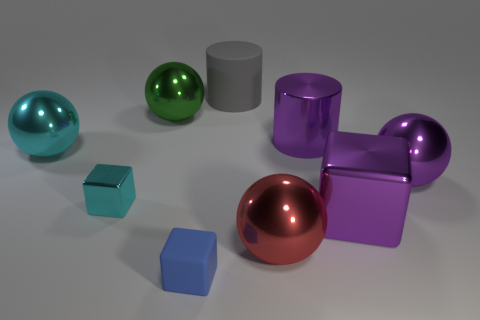Is the number of large shiny objects that are in front of the blue object greater than the number of large red balls?
Give a very brief answer. No. How many other things are there of the same color as the matte cylinder?
Your answer should be compact. 0. There is a gray thing that is the same size as the green metallic ball; what is its shape?
Your response must be concise. Cylinder. How many purple spheres are in front of the purple thing that is in front of the metallic block that is behind the purple block?
Your response must be concise. 0. How many matte things are either large yellow objects or big green objects?
Offer a very short reply. 0. There is a ball that is right of the small matte thing and behind the large cube; what color is it?
Ensure brevity in your answer.  Purple. Do the cylinder in front of the green metal thing and the green metal ball have the same size?
Keep it short and to the point. Yes. What number of things are large things to the right of the big matte cylinder or big red rubber cylinders?
Your response must be concise. 4. Are there any cyan matte cylinders that have the same size as the purple cylinder?
Offer a very short reply. No. There is a object that is the same size as the cyan metal cube; what is its material?
Your answer should be compact. Rubber. 